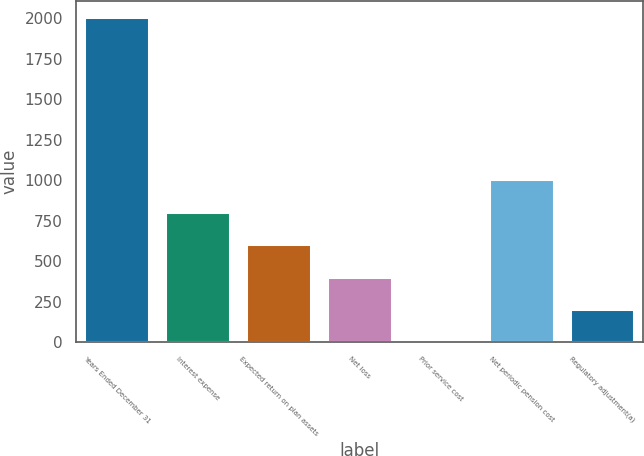Convert chart. <chart><loc_0><loc_0><loc_500><loc_500><bar_chart><fcel>Years Ended December 31<fcel>Interest expense<fcel>Expected return on plan assets<fcel>Net loss<fcel>Prior service cost<fcel>Net periodic pension cost<fcel>Regulatory adjustment(a)<nl><fcel>2006<fcel>806.6<fcel>606.7<fcel>406.8<fcel>7<fcel>1006.5<fcel>206.9<nl></chart> 